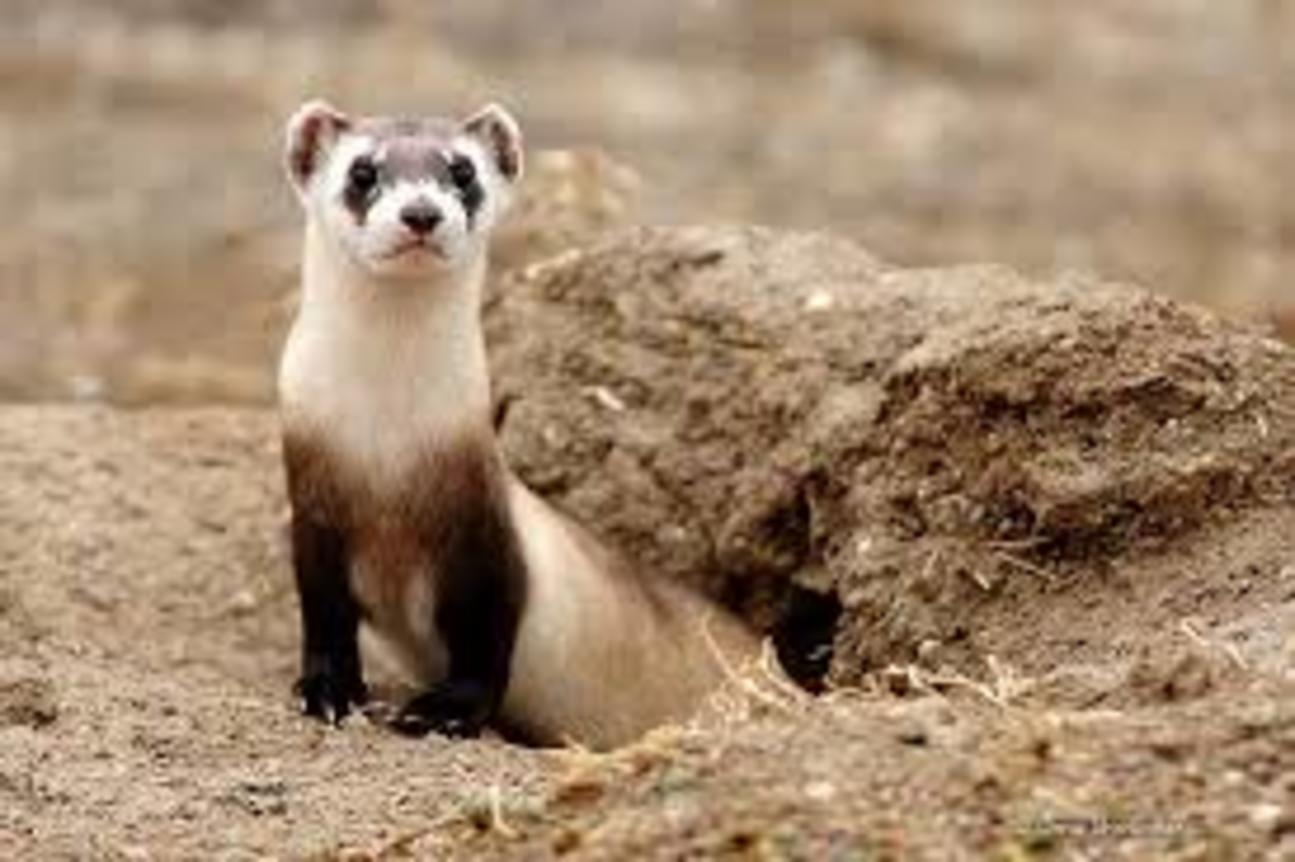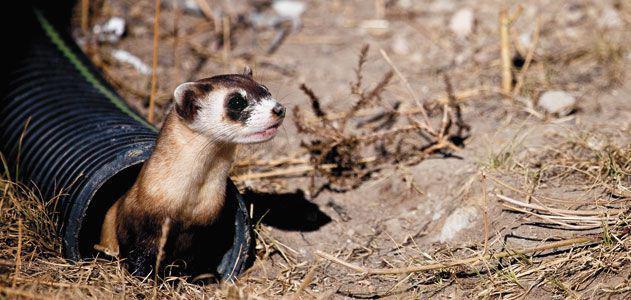The first image is the image on the left, the second image is the image on the right. For the images displayed, is the sentence "There are no more than two ferrets." factually correct? Answer yes or no. Yes. The first image is the image on the left, the second image is the image on the right. Given the left and right images, does the statement "At least one of the animals is partly in a hole." hold true? Answer yes or no. Yes. 